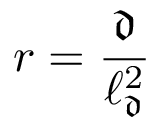Convert formula to latex. <formula><loc_0><loc_0><loc_500><loc_500>r = \frac { \mathfrak { d } } { \ell _ { \mathfrak { d } } ^ { 2 } }</formula> 